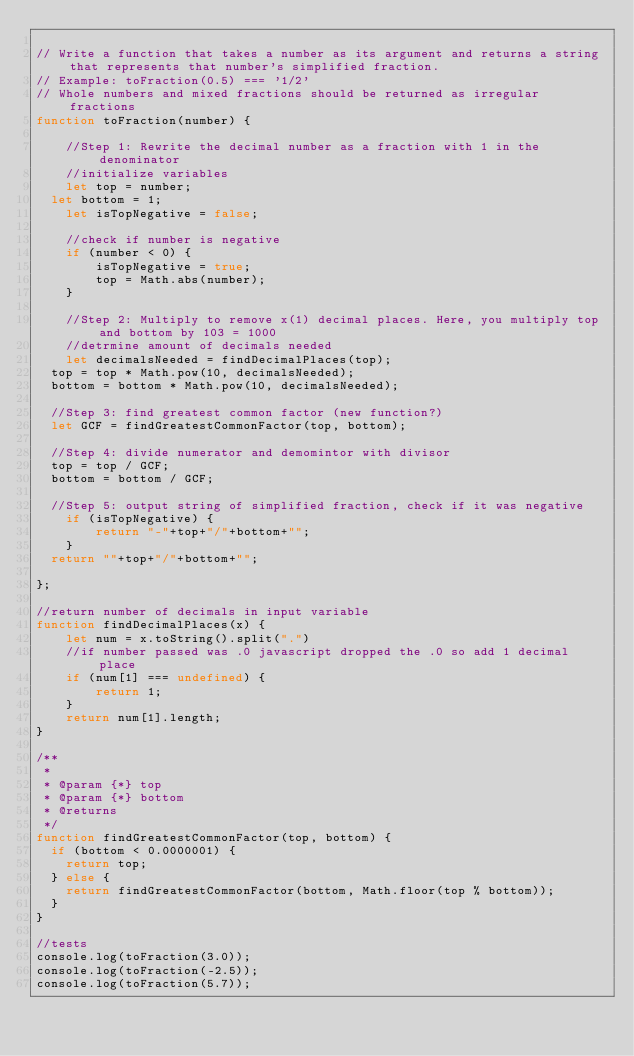<code> <loc_0><loc_0><loc_500><loc_500><_JavaScript_>
// Write a function that takes a number as its argument and returns a string that represents that number's simplified fraction.
// Example: toFraction(0.5) === '1/2'
// Whole numbers and mixed fractions should be returned as irregular fractions
function toFraction(number) {

	//Step 1: Rewrite the decimal number as a fraction with 1 in the denominator
	//initialize variables
	let top = number;
  let bottom = 1;
	let isTopNegative = false;

	//check if number is negative
	if (number < 0) {
		isTopNegative = true;
		top = Math.abs(number);
	}

	//Step 2: Multiply to remove x(1) decimal places. Here, you multiply top and bottom by 103 = 1000
	//detrmine amount of decimals needed
	let decimalsNeeded = findDecimalPlaces(top);
  top = top * Math.pow(10, decimalsNeeded);
  bottom = bottom * Math.pow(10, decimalsNeeded);

  //Step 3: find greatest common factor (new function?)
  let GCF = findGreatestCommonFactor(top, bottom);

  //Step 4: divide numerator and demomintor with divisor
  top = top / GCF;
  bottom = bottom / GCF;

  //Step 5: output string of simplified fraction, check if it was negative
	if (isTopNegative) {
		return "-"+top+"/"+bottom+"";
	}
  return ""+top+"/"+bottom+"";

};

//return number of decimals in input variable
function findDecimalPlaces(x) {
	let num = x.toString().split(".")
	//if number passed was .0 javascript dropped the .0 so add 1 decimal place
	if (num[1] === undefined) {
		return 1;
	}
	return num[1].length;
}

/**
 *
 * @param {*} top
 * @param {*} bottom
 * @returns
 */
function findGreatestCommonFactor(top, bottom) {
  if (bottom < 0.0000001) {
    return top;
  } else {
    return findGreatestCommonFactor(bottom, Math.floor(top % bottom));
  }
}

//tests
console.log(toFraction(3.0));
console.log(toFraction(-2.5));
console.log(toFraction(5.7));</code> 